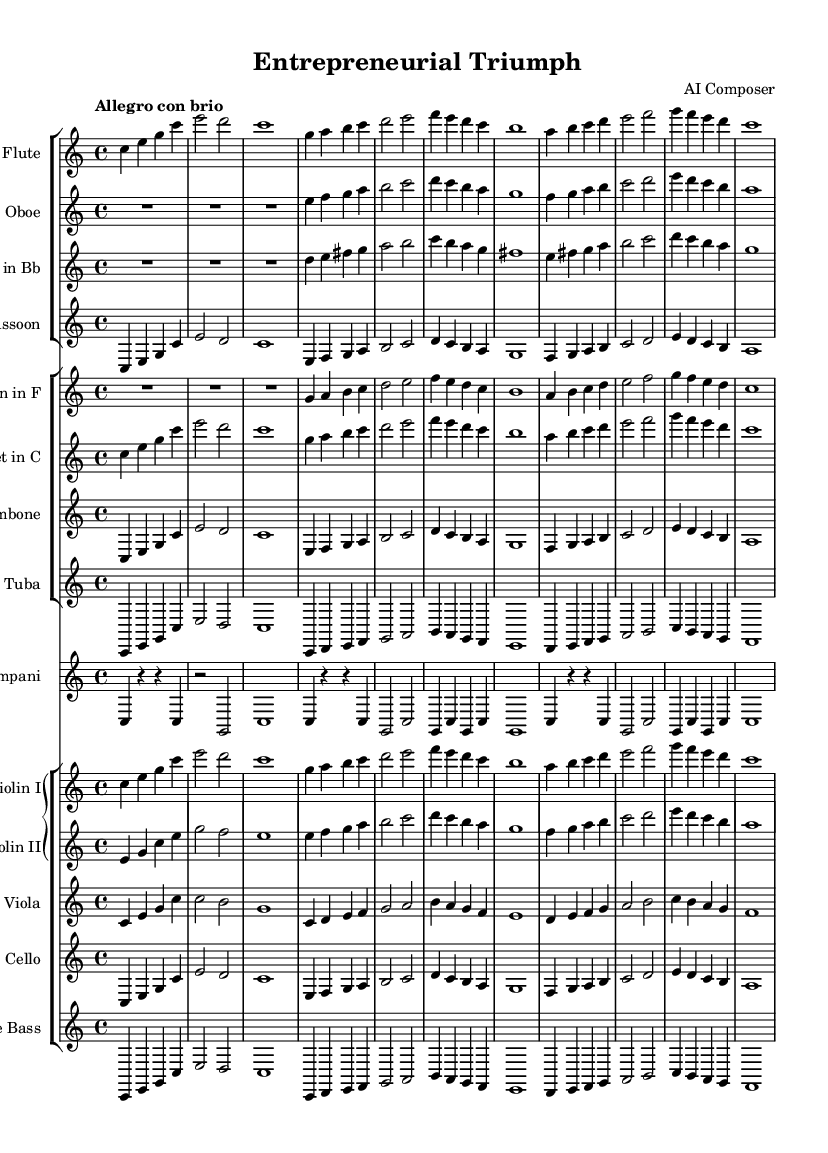What is the key signature of this music? The key signature is based on the global block at the beginning of the code, which specifies C major, indicated by no sharps or flats.
Answer: C major What is the time signature used in this symphony? The time signature is found in the global block; it states 4/4, which signifies four beats per measure with a quarter note getting one beat.
Answer: 4/4 What is the tempo marking for this symphony? The tempo marking is indicated in the global block right after the time signature. The term "Allegro con brio" suggests a lively and brisk tempo.
Answer: Allegro con brio Which instruments are included in the woodwind section? The woodwind section can be identified from the first staff group, which contains flute, oboe, clarinet, and bassoon.
Answer: Flute, Oboe, Clarinet, Bassoon What is the first note played by the Violin I? The first note is found in the staff for Violin I, which starts with the note C.
Answer: C How many measures are in the treble clef for the Violin II part? By counting the measures in the Violin II section of the score, there are a total of 6 measures presented.
Answer: 6 measures Which instrument plays the lowest pitch in this symphony? The instrument that plays the lowest pitch can be determined by looking at the bass staff; the Double Bass is the instrument that plays the lowest range of notes.
Answer: Double Bass 